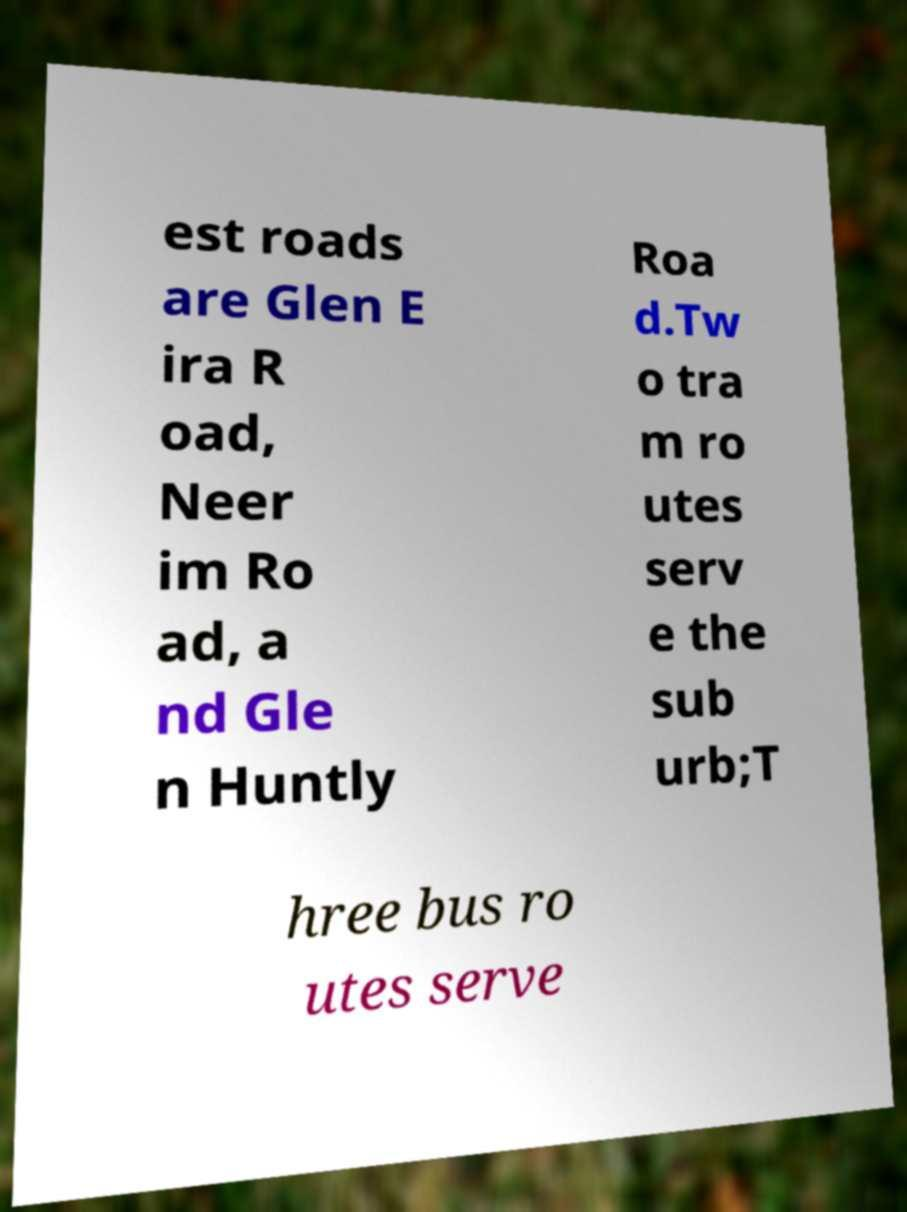For documentation purposes, I need the text within this image transcribed. Could you provide that? est roads are Glen E ira R oad, Neer im Ro ad, a nd Gle n Huntly Roa d.Tw o tra m ro utes serv e the sub urb;T hree bus ro utes serve 